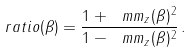<formula> <loc_0><loc_0><loc_500><loc_500>\ r a t i o ( \beta ) = \frac { 1 + \ m m _ { z } ( \beta ) ^ { 2 } } { 1 - \ m m _ { z } ( \beta ) ^ { 2 } } \, .</formula> 